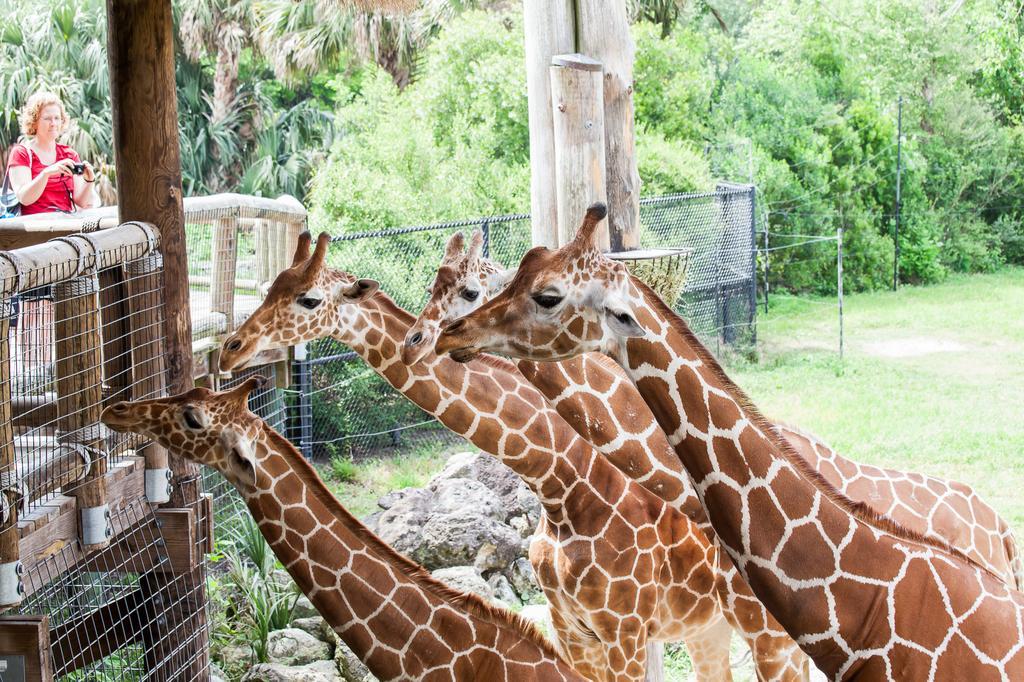Could you give a brief overview of what you see in this image? As we can see in the image there are giraffes, fence, grass, trees and on the left side there is a woman wearing red color dress and holding a camera. 